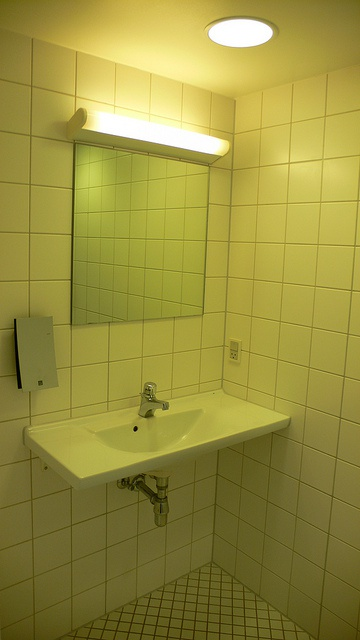Describe the objects in this image and their specific colors. I can see a sink in olive and khaki tones in this image. 